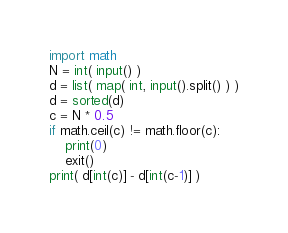Convert code to text. <code><loc_0><loc_0><loc_500><loc_500><_Python_>import math
N = int( input() )
d = list( map( int, input().split() ) )
d = sorted(d)
c = N * 0.5
if math.ceil(c) != math.floor(c):
    print(0)
    exit()
print( d[int(c)] - d[int(c-1)] )</code> 